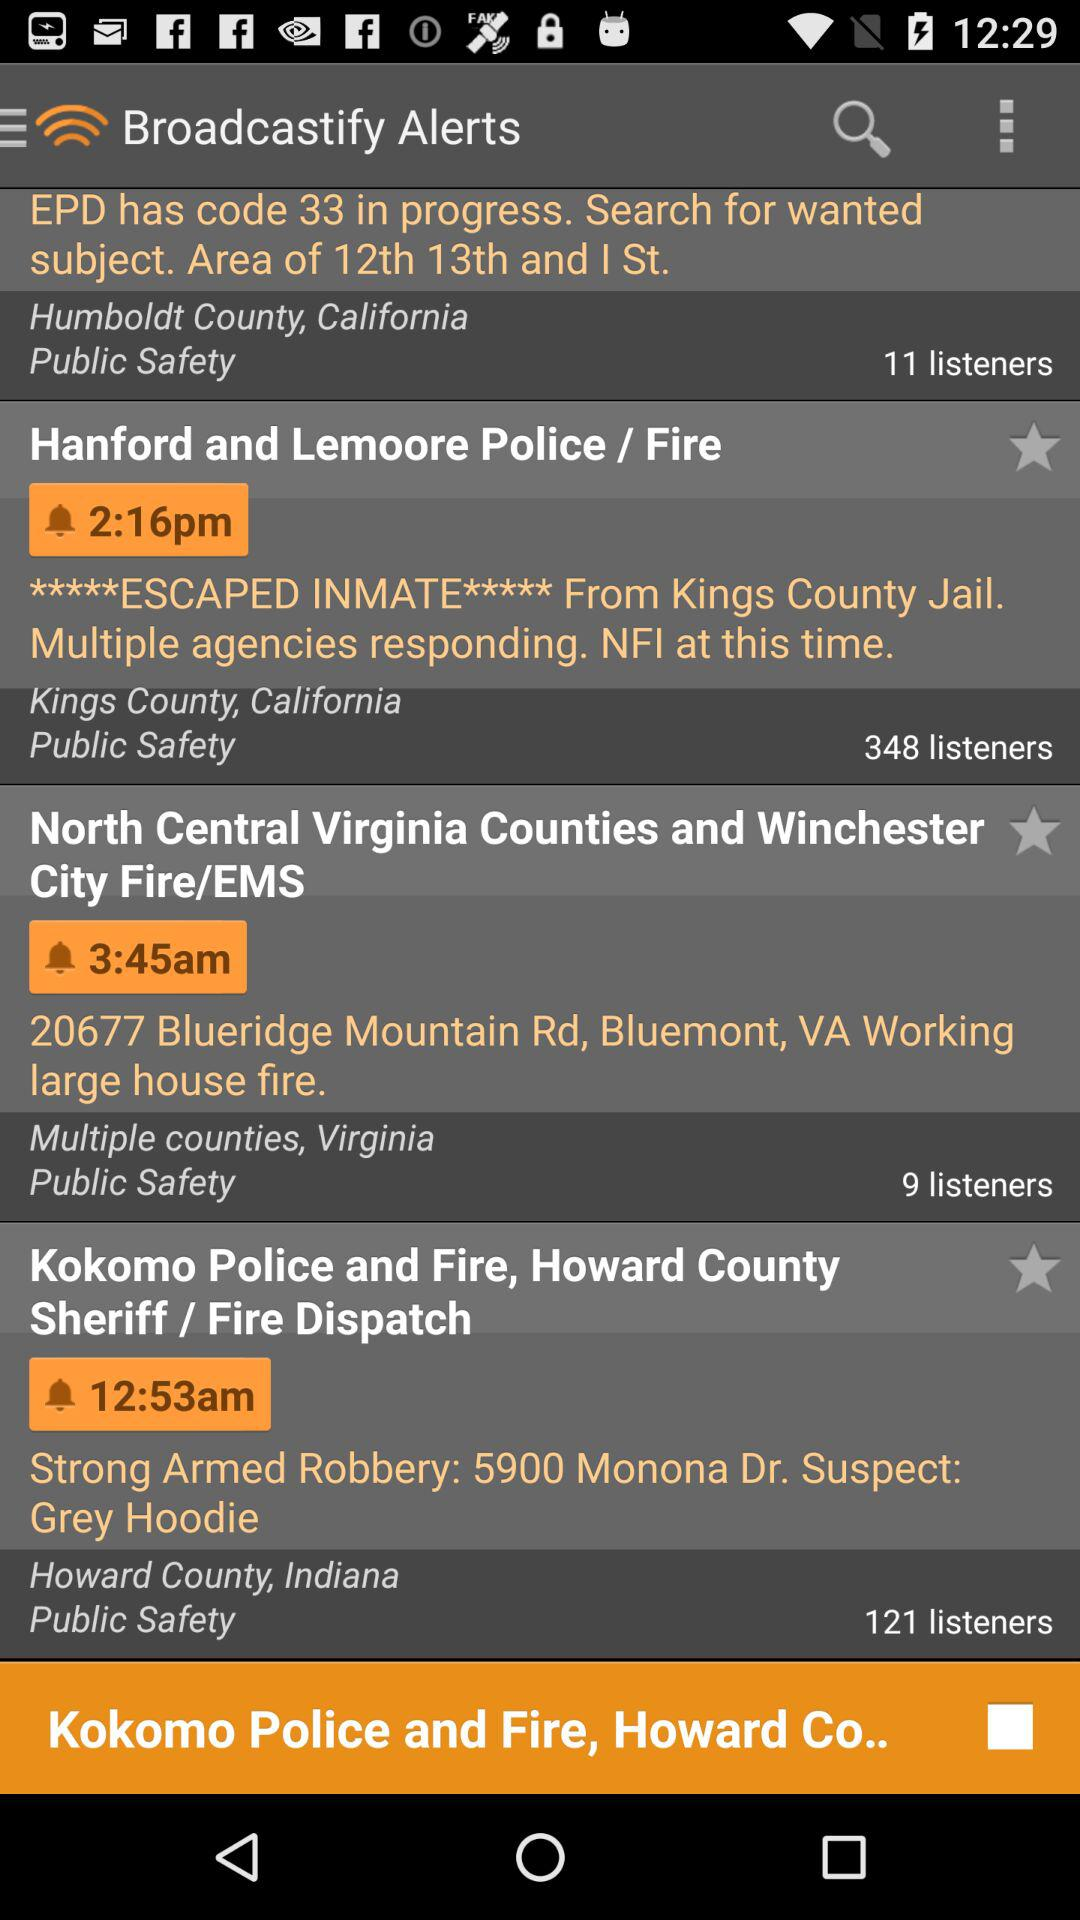What is the location in Virginia having house fire?
When the provided information is insufficient, respond with <no answer>. <no answer> 